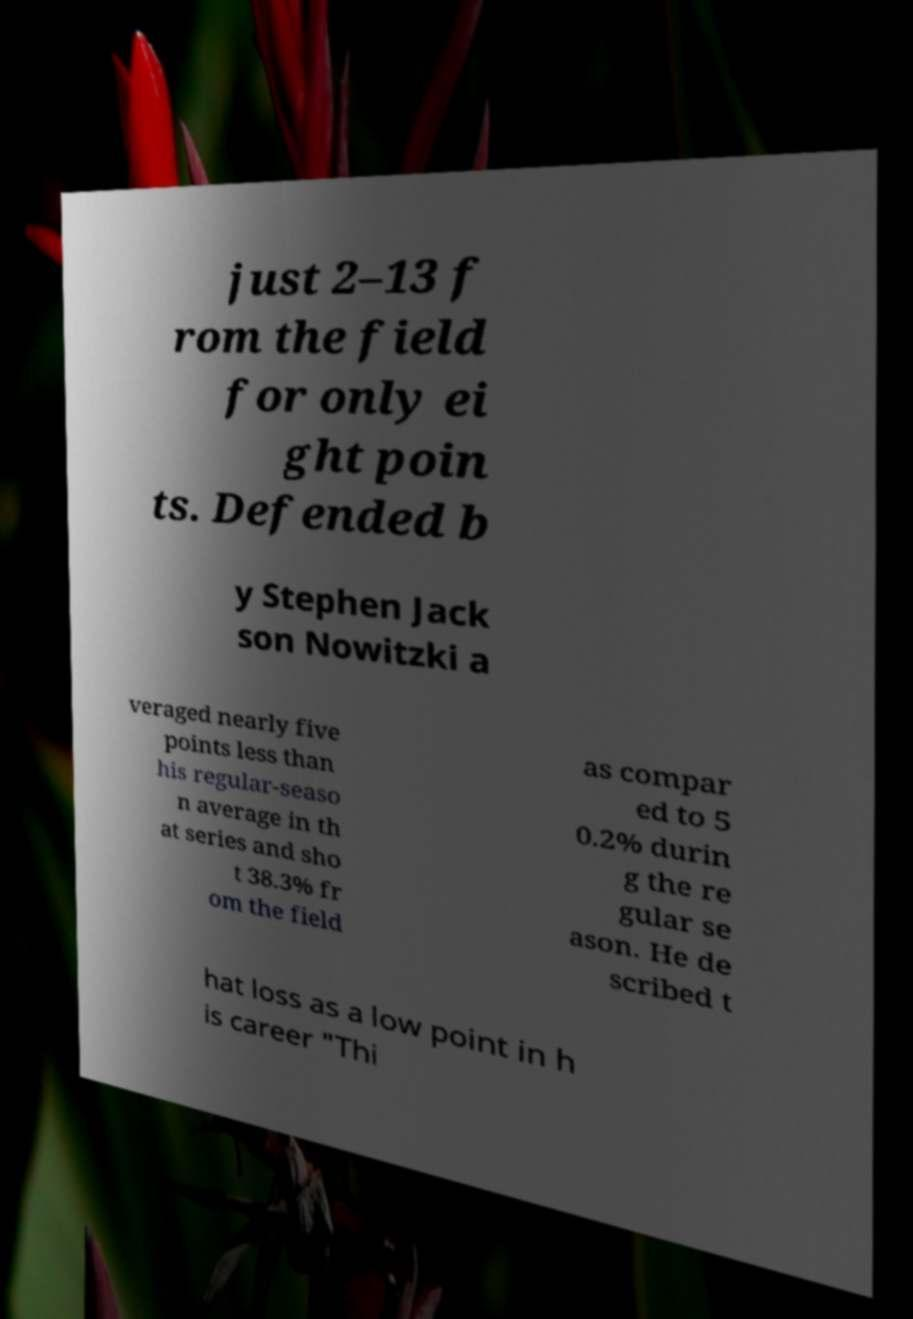I need the written content from this picture converted into text. Can you do that? just 2–13 f rom the field for only ei ght poin ts. Defended b y Stephen Jack son Nowitzki a veraged nearly five points less than his regular-seaso n average in th at series and sho t 38.3% fr om the field as compar ed to 5 0.2% durin g the re gular se ason. He de scribed t hat loss as a low point in h is career "Thi 